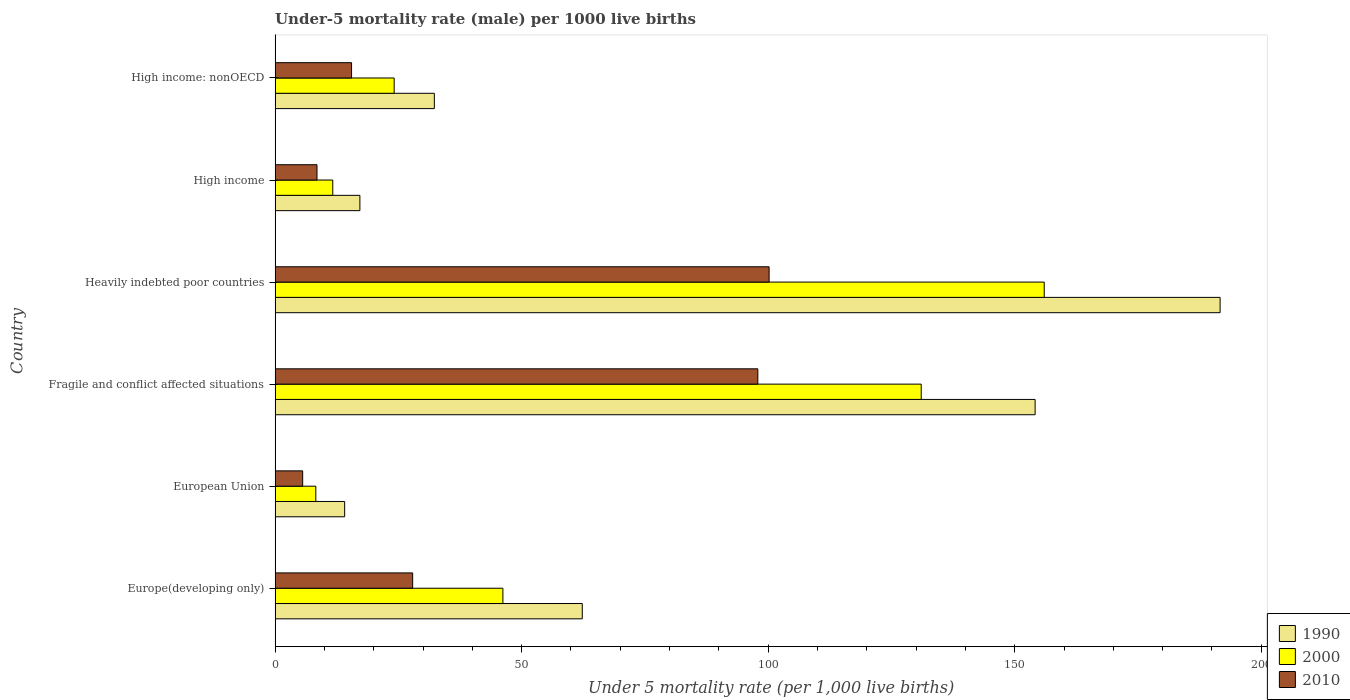How many different coloured bars are there?
Your response must be concise. 3. Are the number of bars on each tick of the Y-axis equal?
Provide a succinct answer. Yes. How many bars are there on the 6th tick from the top?
Provide a succinct answer. 3. How many bars are there on the 6th tick from the bottom?
Provide a short and direct response. 3. What is the label of the 3rd group of bars from the top?
Your answer should be compact. Heavily indebted poor countries. What is the under-five mortality rate in 1990 in High income: nonOECD?
Offer a very short reply. 32.3. Across all countries, what is the maximum under-five mortality rate in 2010?
Offer a terse response. 100.19. Across all countries, what is the minimum under-five mortality rate in 1990?
Provide a short and direct response. 14.11. In which country was the under-five mortality rate in 2010 maximum?
Ensure brevity in your answer.  Heavily indebted poor countries. What is the total under-five mortality rate in 2000 in the graph?
Offer a very short reply. 377.33. What is the difference between the under-five mortality rate in 2000 in European Union and that in Fragile and conflict affected situations?
Offer a very short reply. -122.78. What is the difference between the under-five mortality rate in 2010 in European Union and the under-five mortality rate in 2000 in Fragile and conflict affected situations?
Your answer should be very brief. -125.44. What is the average under-five mortality rate in 1990 per country?
Ensure brevity in your answer.  78.62. What is the difference between the under-five mortality rate in 2010 and under-five mortality rate in 1990 in High income?
Ensure brevity in your answer.  -8.7. In how many countries, is the under-five mortality rate in 2010 greater than 40 ?
Offer a terse response. 2. What is the ratio of the under-five mortality rate in 2000 in Fragile and conflict affected situations to that in High income: nonOECD?
Make the answer very short. 5.43. Is the under-five mortality rate in 2010 in Europe(developing only) less than that in European Union?
Ensure brevity in your answer.  No. What is the difference between the highest and the second highest under-five mortality rate in 2010?
Your answer should be compact. 2.29. What is the difference between the highest and the lowest under-five mortality rate in 2000?
Provide a short and direct response. 147.72. Is the sum of the under-five mortality rate in 2010 in Heavily indebted poor countries and High income greater than the maximum under-five mortality rate in 1990 across all countries?
Your response must be concise. No. Is it the case that in every country, the sum of the under-five mortality rate in 1990 and under-five mortality rate in 2010 is greater than the under-five mortality rate in 2000?
Offer a very short reply. Yes. How many bars are there?
Offer a very short reply. 18. What is the difference between two consecutive major ticks on the X-axis?
Your answer should be compact. 50. Are the values on the major ticks of X-axis written in scientific E-notation?
Give a very brief answer. No. How many legend labels are there?
Give a very brief answer. 3. How are the legend labels stacked?
Provide a short and direct response. Vertical. What is the title of the graph?
Your response must be concise. Under-5 mortality rate (male) per 1000 live births. What is the label or title of the X-axis?
Make the answer very short. Under 5 mortality rate (per 1,0 live births). What is the label or title of the Y-axis?
Make the answer very short. Country. What is the Under 5 mortality rate (per 1,000 live births) of 1990 in Europe(developing only)?
Your answer should be compact. 62.3. What is the Under 5 mortality rate (per 1,000 live births) in 2000 in Europe(developing only)?
Your answer should be compact. 46.2. What is the Under 5 mortality rate (per 1,000 live births) in 2010 in Europe(developing only)?
Your answer should be very brief. 27.9. What is the Under 5 mortality rate (per 1,000 live births) of 1990 in European Union?
Make the answer very short. 14.11. What is the Under 5 mortality rate (per 1,000 live births) in 2000 in European Union?
Keep it short and to the point. 8.26. What is the Under 5 mortality rate (per 1,000 live births) in 2010 in European Union?
Make the answer very short. 5.6. What is the Under 5 mortality rate (per 1,000 live births) of 1990 in Fragile and conflict affected situations?
Your answer should be very brief. 154.14. What is the Under 5 mortality rate (per 1,000 live births) in 2000 in Fragile and conflict affected situations?
Your response must be concise. 131.04. What is the Under 5 mortality rate (per 1,000 live births) of 2010 in Fragile and conflict affected situations?
Provide a short and direct response. 97.9. What is the Under 5 mortality rate (per 1,000 live births) in 1990 in Heavily indebted poor countries?
Keep it short and to the point. 191.65. What is the Under 5 mortality rate (per 1,000 live births) in 2000 in Heavily indebted poor countries?
Your answer should be compact. 155.98. What is the Under 5 mortality rate (per 1,000 live births) in 2010 in Heavily indebted poor countries?
Your answer should be very brief. 100.19. What is the Under 5 mortality rate (per 1,000 live births) of 1990 in High income?
Offer a very short reply. 17.2. What is the Under 5 mortality rate (per 1,000 live births) of 2010 in High income?
Your response must be concise. 8.5. What is the Under 5 mortality rate (per 1,000 live births) in 1990 in High income: nonOECD?
Offer a very short reply. 32.3. What is the Under 5 mortality rate (per 1,000 live births) in 2000 in High income: nonOECD?
Give a very brief answer. 24.15. What is the Under 5 mortality rate (per 1,000 live births) of 2010 in High income: nonOECD?
Keep it short and to the point. 15.51. Across all countries, what is the maximum Under 5 mortality rate (per 1,000 live births) in 1990?
Provide a succinct answer. 191.65. Across all countries, what is the maximum Under 5 mortality rate (per 1,000 live births) of 2000?
Give a very brief answer. 155.98. Across all countries, what is the maximum Under 5 mortality rate (per 1,000 live births) of 2010?
Provide a short and direct response. 100.19. Across all countries, what is the minimum Under 5 mortality rate (per 1,000 live births) of 1990?
Make the answer very short. 14.11. Across all countries, what is the minimum Under 5 mortality rate (per 1,000 live births) in 2000?
Provide a succinct answer. 8.26. Across all countries, what is the minimum Under 5 mortality rate (per 1,000 live births) in 2010?
Offer a very short reply. 5.6. What is the total Under 5 mortality rate (per 1,000 live births) of 1990 in the graph?
Your response must be concise. 471.7. What is the total Under 5 mortality rate (per 1,000 live births) in 2000 in the graph?
Your response must be concise. 377.33. What is the total Under 5 mortality rate (per 1,000 live births) of 2010 in the graph?
Provide a short and direct response. 255.6. What is the difference between the Under 5 mortality rate (per 1,000 live births) of 1990 in Europe(developing only) and that in European Union?
Your response must be concise. 48.19. What is the difference between the Under 5 mortality rate (per 1,000 live births) of 2000 in Europe(developing only) and that in European Union?
Ensure brevity in your answer.  37.94. What is the difference between the Under 5 mortality rate (per 1,000 live births) in 2010 in Europe(developing only) and that in European Union?
Keep it short and to the point. 22.3. What is the difference between the Under 5 mortality rate (per 1,000 live births) of 1990 in Europe(developing only) and that in Fragile and conflict affected situations?
Give a very brief answer. -91.84. What is the difference between the Under 5 mortality rate (per 1,000 live births) in 2000 in Europe(developing only) and that in Fragile and conflict affected situations?
Your response must be concise. -84.84. What is the difference between the Under 5 mortality rate (per 1,000 live births) in 2010 in Europe(developing only) and that in Fragile and conflict affected situations?
Give a very brief answer. -70. What is the difference between the Under 5 mortality rate (per 1,000 live births) in 1990 in Europe(developing only) and that in Heavily indebted poor countries?
Offer a terse response. -129.35. What is the difference between the Under 5 mortality rate (per 1,000 live births) of 2000 in Europe(developing only) and that in Heavily indebted poor countries?
Your answer should be compact. -109.78. What is the difference between the Under 5 mortality rate (per 1,000 live births) of 2010 in Europe(developing only) and that in Heavily indebted poor countries?
Your answer should be compact. -72.29. What is the difference between the Under 5 mortality rate (per 1,000 live births) in 1990 in Europe(developing only) and that in High income?
Your answer should be compact. 45.1. What is the difference between the Under 5 mortality rate (per 1,000 live births) in 2000 in Europe(developing only) and that in High income?
Ensure brevity in your answer.  34.5. What is the difference between the Under 5 mortality rate (per 1,000 live births) of 2010 in Europe(developing only) and that in High income?
Your answer should be compact. 19.4. What is the difference between the Under 5 mortality rate (per 1,000 live births) in 1990 in Europe(developing only) and that in High income: nonOECD?
Provide a succinct answer. 30. What is the difference between the Under 5 mortality rate (per 1,000 live births) in 2000 in Europe(developing only) and that in High income: nonOECD?
Your answer should be very brief. 22.05. What is the difference between the Under 5 mortality rate (per 1,000 live births) of 2010 in Europe(developing only) and that in High income: nonOECD?
Offer a very short reply. 12.39. What is the difference between the Under 5 mortality rate (per 1,000 live births) of 1990 in European Union and that in Fragile and conflict affected situations?
Offer a terse response. -140.03. What is the difference between the Under 5 mortality rate (per 1,000 live births) in 2000 in European Union and that in Fragile and conflict affected situations?
Your answer should be very brief. -122.78. What is the difference between the Under 5 mortality rate (per 1,000 live births) in 2010 in European Union and that in Fragile and conflict affected situations?
Offer a terse response. -92.31. What is the difference between the Under 5 mortality rate (per 1,000 live births) of 1990 in European Union and that in Heavily indebted poor countries?
Your response must be concise. -177.54. What is the difference between the Under 5 mortality rate (per 1,000 live births) of 2000 in European Union and that in Heavily indebted poor countries?
Ensure brevity in your answer.  -147.72. What is the difference between the Under 5 mortality rate (per 1,000 live births) in 2010 in European Union and that in Heavily indebted poor countries?
Your response must be concise. -94.59. What is the difference between the Under 5 mortality rate (per 1,000 live births) of 1990 in European Union and that in High income?
Your response must be concise. -3.09. What is the difference between the Under 5 mortality rate (per 1,000 live births) in 2000 in European Union and that in High income?
Your answer should be compact. -3.44. What is the difference between the Under 5 mortality rate (per 1,000 live births) of 2010 in European Union and that in High income?
Keep it short and to the point. -2.9. What is the difference between the Under 5 mortality rate (per 1,000 live births) of 1990 in European Union and that in High income: nonOECD?
Offer a terse response. -18.19. What is the difference between the Under 5 mortality rate (per 1,000 live births) of 2000 in European Union and that in High income: nonOECD?
Your answer should be very brief. -15.89. What is the difference between the Under 5 mortality rate (per 1,000 live births) of 2010 in European Union and that in High income: nonOECD?
Offer a terse response. -9.92. What is the difference between the Under 5 mortality rate (per 1,000 live births) in 1990 in Fragile and conflict affected situations and that in Heavily indebted poor countries?
Keep it short and to the point. -37.52. What is the difference between the Under 5 mortality rate (per 1,000 live births) in 2000 in Fragile and conflict affected situations and that in Heavily indebted poor countries?
Your response must be concise. -24.95. What is the difference between the Under 5 mortality rate (per 1,000 live births) in 2010 in Fragile and conflict affected situations and that in Heavily indebted poor countries?
Offer a very short reply. -2.29. What is the difference between the Under 5 mortality rate (per 1,000 live births) of 1990 in Fragile and conflict affected situations and that in High income?
Offer a terse response. 136.94. What is the difference between the Under 5 mortality rate (per 1,000 live births) of 2000 in Fragile and conflict affected situations and that in High income?
Offer a terse response. 119.34. What is the difference between the Under 5 mortality rate (per 1,000 live births) in 2010 in Fragile and conflict affected situations and that in High income?
Make the answer very short. 89.4. What is the difference between the Under 5 mortality rate (per 1,000 live births) in 1990 in Fragile and conflict affected situations and that in High income: nonOECD?
Your response must be concise. 121.84. What is the difference between the Under 5 mortality rate (per 1,000 live births) in 2000 in Fragile and conflict affected situations and that in High income: nonOECD?
Your response must be concise. 106.89. What is the difference between the Under 5 mortality rate (per 1,000 live births) in 2010 in Fragile and conflict affected situations and that in High income: nonOECD?
Offer a very short reply. 82.39. What is the difference between the Under 5 mortality rate (per 1,000 live births) of 1990 in Heavily indebted poor countries and that in High income?
Your answer should be compact. 174.45. What is the difference between the Under 5 mortality rate (per 1,000 live births) of 2000 in Heavily indebted poor countries and that in High income?
Your answer should be compact. 144.28. What is the difference between the Under 5 mortality rate (per 1,000 live births) in 2010 in Heavily indebted poor countries and that in High income?
Offer a very short reply. 91.69. What is the difference between the Under 5 mortality rate (per 1,000 live births) in 1990 in Heavily indebted poor countries and that in High income: nonOECD?
Your response must be concise. 159.36. What is the difference between the Under 5 mortality rate (per 1,000 live births) of 2000 in Heavily indebted poor countries and that in High income: nonOECD?
Make the answer very short. 131.83. What is the difference between the Under 5 mortality rate (per 1,000 live births) in 2010 in Heavily indebted poor countries and that in High income: nonOECD?
Keep it short and to the point. 84.68. What is the difference between the Under 5 mortality rate (per 1,000 live births) in 1990 in High income and that in High income: nonOECD?
Offer a terse response. -15.1. What is the difference between the Under 5 mortality rate (per 1,000 live births) of 2000 in High income and that in High income: nonOECD?
Your response must be concise. -12.45. What is the difference between the Under 5 mortality rate (per 1,000 live births) of 2010 in High income and that in High income: nonOECD?
Provide a succinct answer. -7.01. What is the difference between the Under 5 mortality rate (per 1,000 live births) of 1990 in Europe(developing only) and the Under 5 mortality rate (per 1,000 live births) of 2000 in European Union?
Provide a short and direct response. 54.04. What is the difference between the Under 5 mortality rate (per 1,000 live births) of 1990 in Europe(developing only) and the Under 5 mortality rate (per 1,000 live births) of 2010 in European Union?
Provide a succinct answer. 56.7. What is the difference between the Under 5 mortality rate (per 1,000 live births) in 2000 in Europe(developing only) and the Under 5 mortality rate (per 1,000 live births) in 2010 in European Union?
Your answer should be very brief. 40.6. What is the difference between the Under 5 mortality rate (per 1,000 live births) of 1990 in Europe(developing only) and the Under 5 mortality rate (per 1,000 live births) of 2000 in Fragile and conflict affected situations?
Your answer should be very brief. -68.74. What is the difference between the Under 5 mortality rate (per 1,000 live births) of 1990 in Europe(developing only) and the Under 5 mortality rate (per 1,000 live births) of 2010 in Fragile and conflict affected situations?
Your response must be concise. -35.6. What is the difference between the Under 5 mortality rate (per 1,000 live births) in 2000 in Europe(developing only) and the Under 5 mortality rate (per 1,000 live births) in 2010 in Fragile and conflict affected situations?
Keep it short and to the point. -51.7. What is the difference between the Under 5 mortality rate (per 1,000 live births) in 1990 in Europe(developing only) and the Under 5 mortality rate (per 1,000 live births) in 2000 in Heavily indebted poor countries?
Make the answer very short. -93.68. What is the difference between the Under 5 mortality rate (per 1,000 live births) in 1990 in Europe(developing only) and the Under 5 mortality rate (per 1,000 live births) in 2010 in Heavily indebted poor countries?
Offer a very short reply. -37.89. What is the difference between the Under 5 mortality rate (per 1,000 live births) in 2000 in Europe(developing only) and the Under 5 mortality rate (per 1,000 live births) in 2010 in Heavily indebted poor countries?
Offer a terse response. -53.99. What is the difference between the Under 5 mortality rate (per 1,000 live births) in 1990 in Europe(developing only) and the Under 5 mortality rate (per 1,000 live births) in 2000 in High income?
Provide a succinct answer. 50.6. What is the difference between the Under 5 mortality rate (per 1,000 live births) of 1990 in Europe(developing only) and the Under 5 mortality rate (per 1,000 live births) of 2010 in High income?
Keep it short and to the point. 53.8. What is the difference between the Under 5 mortality rate (per 1,000 live births) of 2000 in Europe(developing only) and the Under 5 mortality rate (per 1,000 live births) of 2010 in High income?
Make the answer very short. 37.7. What is the difference between the Under 5 mortality rate (per 1,000 live births) of 1990 in Europe(developing only) and the Under 5 mortality rate (per 1,000 live births) of 2000 in High income: nonOECD?
Give a very brief answer. 38.15. What is the difference between the Under 5 mortality rate (per 1,000 live births) in 1990 in Europe(developing only) and the Under 5 mortality rate (per 1,000 live births) in 2010 in High income: nonOECD?
Your answer should be very brief. 46.79. What is the difference between the Under 5 mortality rate (per 1,000 live births) in 2000 in Europe(developing only) and the Under 5 mortality rate (per 1,000 live births) in 2010 in High income: nonOECD?
Your response must be concise. 30.69. What is the difference between the Under 5 mortality rate (per 1,000 live births) in 1990 in European Union and the Under 5 mortality rate (per 1,000 live births) in 2000 in Fragile and conflict affected situations?
Provide a succinct answer. -116.93. What is the difference between the Under 5 mortality rate (per 1,000 live births) of 1990 in European Union and the Under 5 mortality rate (per 1,000 live births) of 2010 in Fragile and conflict affected situations?
Your answer should be very brief. -83.79. What is the difference between the Under 5 mortality rate (per 1,000 live births) of 2000 in European Union and the Under 5 mortality rate (per 1,000 live births) of 2010 in Fragile and conflict affected situations?
Provide a succinct answer. -89.64. What is the difference between the Under 5 mortality rate (per 1,000 live births) of 1990 in European Union and the Under 5 mortality rate (per 1,000 live births) of 2000 in Heavily indebted poor countries?
Your response must be concise. -141.87. What is the difference between the Under 5 mortality rate (per 1,000 live births) of 1990 in European Union and the Under 5 mortality rate (per 1,000 live births) of 2010 in Heavily indebted poor countries?
Your response must be concise. -86.08. What is the difference between the Under 5 mortality rate (per 1,000 live births) of 2000 in European Union and the Under 5 mortality rate (per 1,000 live births) of 2010 in Heavily indebted poor countries?
Make the answer very short. -91.93. What is the difference between the Under 5 mortality rate (per 1,000 live births) of 1990 in European Union and the Under 5 mortality rate (per 1,000 live births) of 2000 in High income?
Keep it short and to the point. 2.41. What is the difference between the Under 5 mortality rate (per 1,000 live births) in 1990 in European Union and the Under 5 mortality rate (per 1,000 live births) in 2010 in High income?
Keep it short and to the point. 5.61. What is the difference between the Under 5 mortality rate (per 1,000 live births) of 2000 in European Union and the Under 5 mortality rate (per 1,000 live births) of 2010 in High income?
Your answer should be very brief. -0.24. What is the difference between the Under 5 mortality rate (per 1,000 live births) in 1990 in European Union and the Under 5 mortality rate (per 1,000 live births) in 2000 in High income: nonOECD?
Provide a succinct answer. -10.04. What is the difference between the Under 5 mortality rate (per 1,000 live births) of 1990 in European Union and the Under 5 mortality rate (per 1,000 live births) of 2010 in High income: nonOECD?
Your answer should be very brief. -1.4. What is the difference between the Under 5 mortality rate (per 1,000 live births) in 2000 in European Union and the Under 5 mortality rate (per 1,000 live births) in 2010 in High income: nonOECD?
Provide a succinct answer. -7.25. What is the difference between the Under 5 mortality rate (per 1,000 live births) in 1990 in Fragile and conflict affected situations and the Under 5 mortality rate (per 1,000 live births) in 2000 in Heavily indebted poor countries?
Provide a succinct answer. -1.85. What is the difference between the Under 5 mortality rate (per 1,000 live births) of 1990 in Fragile and conflict affected situations and the Under 5 mortality rate (per 1,000 live births) of 2010 in Heavily indebted poor countries?
Ensure brevity in your answer.  53.95. What is the difference between the Under 5 mortality rate (per 1,000 live births) in 2000 in Fragile and conflict affected situations and the Under 5 mortality rate (per 1,000 live births) in 2010 in Heavily indebted poor countries?
Give a very brief answer. 30.85. What is the difference between the Under 5 mortality rate (per 1,000 live births) in 1990 in Fragile and conflict affected situations and the Under 5 mortality rate (per 1,000 live births) in 2000 in High income?
Give a very brief answer. 142.44. What is the difference between the Under 5 mortality rate (per 1,000 live births) in 1990 in Fragile and conflict affected situations and the Under 5 mortality rate (per 1,000 live births) in 2010 in High income?
Make the answer very short. 145.64. What is the difference between the Under 5 mortality rate (per 1,000 live births) in 2000 in Fragile and conflict affected situations and the Under 5 mortality rate (per 1,000 live births) in 2010 in High income?
Give a very brief answer. 122.54. What is the difference between the Under 5 mortality rate (per 1,000 live births) in 1990 in Fragile and conflict affected situations and the Under 5 mortality rate (per 1,000 live births) in 2000 in High income: nonOECD?
Make the answer very short. 129.99. What is the difference between the Under 5 mortality rate (per 1,000 live births) in 1990 in Fragile and conflict affected situations and the Under 5 mortality rate (per 1,000 live births) in 2010 in High income: nonOECD?
Your answer should be very brief. 138.63. What is the difference between the Under 5 mortality rate (per 1,000 live births) in 2000 in Fragile and conflict affected situations and the Under 5 mortality rate (per 1,000 live births) in 2010 in High income: nonOECD?
Offer a very short reply. 115.52. What is the difference between the Under 5 mortality rate (per 1,000 live births) in 1990 in Heavily indebted poor countries and the Under 5 mortality rate (per 1,000 live births) in 2000 in High income?
Your response must be concise. 179.95. What is the difference between the Under 5 mortality rate (per 1,000 live births) in 1990 in Heavily indebted poor countries and the Under 5 mortality rate (per 1,000 live births) in 2010 in High income?
Provide a succinct answer. 183.15. What is the difference between the Under 5 mortality rate (per 1,000 live births) of 2000 in Heavily indebted poor countries and the Under 5 mortality rate (per 1,000 live births) of 2010 in High income?
Your answer should be compact. 147.48. What is the difference between the Under 5 mortality rate (per 1,000 live births) of 1990 in Heavily indebted poor countries and the Under 5 mortality rate (per 1,000 live births) of 2000 in High income: nonOECD?
Your response must be concise. 167.5. What is the difference between the Under 5 mortality rate (per 1,000 live births) of 1990 in Heavily indebted poor countries and the Under 5 mortality rate (per 1,000 live births) of 2010 in High income: nonOECD?
Give a very brief answer. 176.14. What is the difference between the Under 5 mortality rate (per 1,000 live births) in 2000 in Heavily indebted poor countries and the Under 5 mortality rate (per 1,000 live births) in 2010 in High income: nonOECD?
Give a very brief answer. 140.47. What is the difference between the Under 5 mortality rate (per 1,000 live births) of 1990 in High income and the Under 5 mortality rate (per 1,000 live births) of 2000 in High income: nonOECD?
Make the answer very short. -6.95. What is the difference between the Under 5 mortality rate (per 1,000 live births) in 1990 in High income and the Under 5 mortality rate (per 1,000 live births) in 2010 in High income: nonOECD?
Your answer should be very brief. 1.69. What is the difference between the Under 5 mortality rate (per 1,000 live births) in 2000 in High income and the Under 5 mortality rate (per 1,000 live births) in 2010 in High income: nonOECD?
Your response must be concise. -3.81. What is the average Under 5 mortality rate (per 1,000 live births) in 1990 per country?
Make the answer very short. 78.62. What is the average Under 5 mortality rate (per 1,000 live births) of 2000 per country?
Offer a very short reply. 62.89. What is the average Under 5 mortality rate (per 1,000 live births) in 2010 per country?
Offer a terse response. 42.6. What is the difference between the Under 5 mortality rate (per 1,000 live births) of 1990 and Under 5 mortality rate (per 1,000 live births) of 2000 in Europe(developing only)?
Ensure brevity in your answer.  16.1. What is the difference between the Under 5 mortality rate (per 1,000 live births) of 1990 and Under 5 mortality rate (per 1,000 live births) of 2010 in Europe(developing only)?
Ensure brevity in your answer.  34.4. What is the difference between the Under 5 mortality rate (per 1,000 live births) of 1990 and Under 5 mortality rate (per 1,000 live births) of 2000 in European Union?
Offer a very short reply. 5.85. What is the difference between the Under 5 mortality rate (per 1,000 live births) of 1990 and Under 5 mortality rate (per 1,000 live births) of 2010 in European Union?
Give a very brief answer. 8.51. What is the difference between the Under 5 mortality rate (per 1,000 live births) of 2000 and Under 5 mortality rate (per 1,000 live births) of 2010 in European Union?
Ensure brevity in your answer.  2.66. What is the difference between the Under 5 mortality rate (per 1,000 live births) of 1990 and Under 5 mortality rate (per 1,000 live births) of 2000 in Fragile and conflict affected situations?
Offer a terse response. 23.1. What is the difference between the Under 5 mortality rate (per 1,000 live births) in 1990 and Under 5 mortality rate (per 1,000 live births) in 2010 in Fragile and conflict affected situations?
Keep it short and to the point. 56.23. What is the difference between the Under 5 mortality rate (per 1,000 live births) of 2000 and Under 5 mortality rate (per 1,000 live births) of 2010 in Fragile and conflict affected situations?
Offer a very short reply. 33.13. What is the difference between the Under 5 mortality rate (per 1,000 live births) of 1990 and Under 5 mortality rate (per 1,000 live births) of 2000 in Heavily indebted poor countries?
Your response must be concise. 35.67. What is the difference between the Under 5 mortality rate (per 1,000 live births) in 1990 and Under 5 mortality rate (per 1,000 live births) in 2010 in Heavily indebted poor countries?
Your answer should be very brief. 91.46. What is the difference between the Under 5 mortality rate (per 1,000 live births) of 2000 and Under 5 mortality rate (per 1,000 live births) of 2010 in Heavily indebted poor countries?
Your answer should be compact. 55.79. What is the difference between the Under 5 mortality rate (per 1,000 live births) of 1990 and Under 5 mortality rate (per 1,000 live births) of 2000 in High income?
Your answer should be very brief. 5.5. What is the difference between the Under 5 mortality rate (per 1,000 live births) of 1990 and Under 5 mortality rate (per 1,000 live births) of 2010 in High income?
Your answer should be very brief. 8.7. What is the difference between the Under 5 mortality rate (per 1,000 live births) of 2000 and Under 5 mortality rate (per 1,000 live births) of 2010 in High income?
Offer a very short reply. 3.2. What is the difference between the Under 5 mortality rate (per 1,000 live births) of 1990 and Under 5 mortality rate (per 1,000 live births) of 2000 in High income: nonOECD?
Ensure brevity in your answer.  8.15. What is the difference between the Under 5 mortality rate (per 1,000 live births) of 1990 and Under 5 mortality rate (per 1,000 live births) of 2010 in High income: nonOECD?
Your response must be concise. 16.79. What is the difference between the Under 5 mortality rate (per 1,000 live births) in 2000 and Under 5 mortality rate (per 1,000 live births) in 2010 in High income: nonOECD?
Offer a terse response. 8.64. What is the ratio of the Under 5 mortality rate (per 1,000 live births) of 1990 in Europe(developing only) to that in European Union?
Your answer should be very brief. 4.42. What is the ratio of the Under 5 mortality rate (per 1,000 live births) of 2000 in Europe(developing only) to that in European Union?
Provide a succinct answer. 5.59. What is the ratio of the Under 5 mortality rate (per 1,000 live births) of 2010 in Europe(developing only) to that in European Union?
Give a very brief answer. 4.99. What is the ratio of the Under 5 mortality rate (per 1,000 live births) in 1990 in Europe(developing only) to that in Fragile and conflict affected situations?
Ensure brevity in your answer.  0.4. What is the ratio of the Under 5 mortality rate (per 1,000 live births) in 2000 in Europe(developing only) to that in Fragile and conflict affected situations?
Provide a short and direct response. 0.35. What is the ratio of the Under 5 mortality rate (per 1,000 live births) in 2010 in Europe(developing only) to that in Fragile and conflict affected situations?
Your answer should be compact. 0.28. What is the ratio of the Under 5 mortality rate (per 1,000 live births) in 1990 in Europe(developing only) to that in Heavily indebted poor countries?
Offer a very short reply. 0.33. What is the ratio of the Under 5 mortality rate (per 1,000 live births) of 2000 in Europe(developing only) to that in Heavily indebted poor countries?
Ensure brevity in your answer.  0.3. What is the ratio of the Under 5 mortality rate (per 1,000 live births) of 2010 in Europe(developing only) to that in Heavily indebted poor countries?
Ensure brevity in your answer.  0.28. What is the ratio of the Under 5 mortality rate (per 1,000 live births) of 1990 in Europe(developing only) to that in High income?
Offer a terse response. 3.62. What is the ratio of the Under 5 mortality rate (per 1,000 live births) in 2000 in Europe(developing only) to that in High income?
Offer a very short reply. 3.95. What is the ratio of the Under 5 mortality rate (per 1,000 live births) in 2010 in Europe(developing only) to that in High income?
Give a very brief answer. 3.28. What is the ratio of the Under 5 mortality rate (per 1,000 live births) of 1990 in Europe(developing only) to that in High income: nonOECD?
Provide a succinct answer. 1.93. What is the ratio of the Under 5 mortality rate (per 1,000 live births) of 2000 in Europe(developing only) to that in High income: nonOECD?
Ensure brevity in your answer.  1.91. What is the ratio of the Under 5 mortality rate (per 1,000 live births) in 2010 in Europe(developing only) to that in High income: nonOECD?
Provide a short and direct response. 1.8. What is the ratio of the Under 5 mortality rate (per 1,000 live births) in 1990 in European Union to that in Fragile and conflict affected situations?
Your response must be concise. 0.09. What is the ratio of the Under 5 mortality rate (per 1,000 live births) of 2000 in European Union to that in Fragile and conflict affected situations?
Provide a short and direct response. 0.06. What is the ratio of the Under 5 mortality rate (per 1,000 live births) in 2010 in European Union to that in Fragile and conflict affected situations?
Offer a terse response. 0.06. What is the ratio of the Under 5 mortality rate (per 1,000 live births) in 1990 in European Union to that in Heavily indebted poor countries?
Give a very brief answer. 0.07. What is the ratio of the Under 5 mortality rate (per 1,000 live births) of 2000 in European Union to that in Heavily indebted poor countries?
Your answer should be very brief. 0.05. What is the ratio of the Under 5 mortality rate (per 1,000 live births) of 2010 in European Union to that in Heavily indebted poor countries?
Your answer should be very brief. 0.06. What is the ratio of the Under 5 mortality rate (per 1,000 live births) in 1990 in European Union to that in High income?
Give a very brief answer. 0.82. What is the ratio of the Under 5 mortality rate (per 1,000 live births) of 2000 in European Union to that in High income?
Ensure brevity in your answer.  0.71. What is the ratio of the Under 5 mortality rate (per 1,000 live births) of 2010 in European Union to that in High income?
Your answer should be very brief. 0.66. What is the ratio of the Under 5 mortality rate (per 1,000 live births) in 1990 in European Union to that in High income: nonOECD?
Offer a very short reply. 0.44. What is the ratio of the Under 5 mortality rate (per 1,000 live births) of 2000 in European Union to that in High income: nonOECD?
Offer a very short reply. 0.34. What is the ratio of the Under 5 mortality rate (per 1,000 live births) of 2010 in European Union to that in High income: nonOECD?
Provide a succinct answer. 0.36. What is the ratio of the Under 5 mortality rate (per 1,000 live births) in 1990 in Fragile and conflict affected situations to that in Heavily indebted poor countries?
Your answer should be compact. 0.8. What is the ratio of the Under 5 mortality rate (per 1,000 live births) in 2000 in Fragile and conflict affected situations to that in Heavily indebted poor countries?
Offer a very short reply. 0.84. What is the ratio of the Under 5 mortality rate (per 1,000 live births) in 2010 in Fragile and conflict affected situations to that in Heavily indebted poor countries?
Offer a very short reply. 0.98. What is the ratio of the Under 5 mortality rate (per 1,000 live births) in 1990 in Fragile and conflict affected situations to that in High income?
Provide a succinct answer. 8.96. What is the ratio of the Under 5 mortality rate (per 1,000 live births) in 2000 in Fragile and conflict affected situations to that in High income?
Give a very brief answer. 11.2. What is the ratio of the Under 5 mortality rate (per 1,000 live births) in 2010 in Fragile and conflict affected situations to that in High income?
Offer a terse response. 11.52. What is the ratio of the Under 5 mortality rate (per 1,000 live births) in 1990 in Fragile and conflict affected situations to that in High income: nonOECD?
Offer a terse response. 4.77. What is the ratio of the Under 5 mortality rate (per 1,000 live births) of 2000 in Fragile and conflict affected situations to that in High income: nonOECD?
Offer a very short reply. 5.43. What is the ratio of the Under 5 mortality rate (per 1,000 live births) in 2010 in Fragile and conflict affected situations to that in High income: nonOECD?
Ensure brevity in your answer.  6.31. What is the ratio of the Under 5 mortality rate (per 1,000 live births) of 1990 in Heavily indebted poor countries to that in High income?
Make the answer very short. 11.14. What is the ratio of the Under 5 mortality rate (per 1,000 live births) in 2000 in Heavily indebted poor countries to that in High income?
Provide a succinct answer. 13.33. What is the ratio of the Under 5 mortality rate (per 1,000 live births) in 2010 in Heavily indebted poor countries to that in High income?
Your answer should be compact. 11.79. What is the ratio of the Under 5 mortality rate (per 1,000 live births) of 1990 in Heavily indebted poor countries to that in High income: nonOECD?
Your answer should be compact. 5.93. What is the ratio of the Under 5 mortality rate (per 1,000 live births) in 2000 in Heavily indebted poor countries to that in High income: nonOECD?
Offer a terse response. 6.46. What is the ratio of the Under 5 mortality rate (per 1,000 live births) of 2010 in Heavily indebted poor countries to that in High income: nonOECD?
Your answer should be compact. 6.46. What is the ratio of the Under 5 mortality rate (per 1,000 live births) of 1990 in High income to that in High income: nonOECD?
Offer a very short reply. 0.53. What is the ratio of the Under 5 mortality rate (per 1,000 live births) in 2000 in High income to that in High income: nonOECD?
Make the answer very short. 0.48. What is the ratio of the Under 5 mortality rate (per 1,000 live births) in 2010 in High income to that in High income: nonOECD?
Make the answer very short. 0.55. What is the difference between the highest and the second highest Under 5 mortality rate (per 1,000 live births) in 1990?
Provide a succinct answer. 37.52. What is the difference between the highest and the second highest Under 5 mortality rate (per 1,000 live births) of 2000?
Offer a terse response. 24.95. What is the difference between the highest and the second highest Under 5 mortality rate (per 1,000 live births) of 2010?
Offer a very short reply. 2.29. What is the difference between the highest and the lowest Under 5 mortality rate (per 1,000 live births) in 1990?
Keep it short and to the point. 177.54. What is the difference between the highest and the lowest Under 5 mortality rate (per 1,000 live births) in 2000?
Your answer should be compact. 147.72. What is the difference between the highest and the lowest Under 5 mortality rate (per 1,000 live births) in 2010?
Keep it short and to the point. 94.59. 